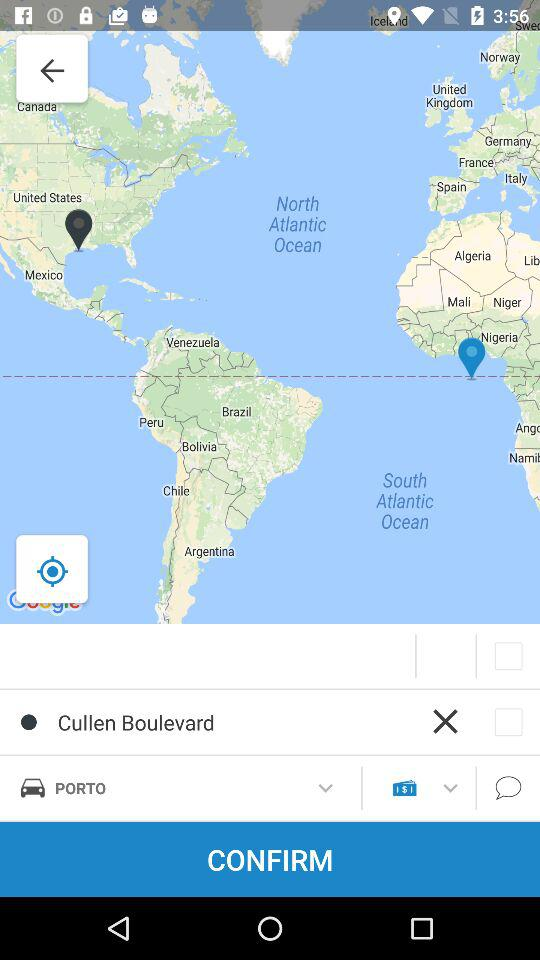What is the location selected on the map? The selected location is Cullen Boulevard. 